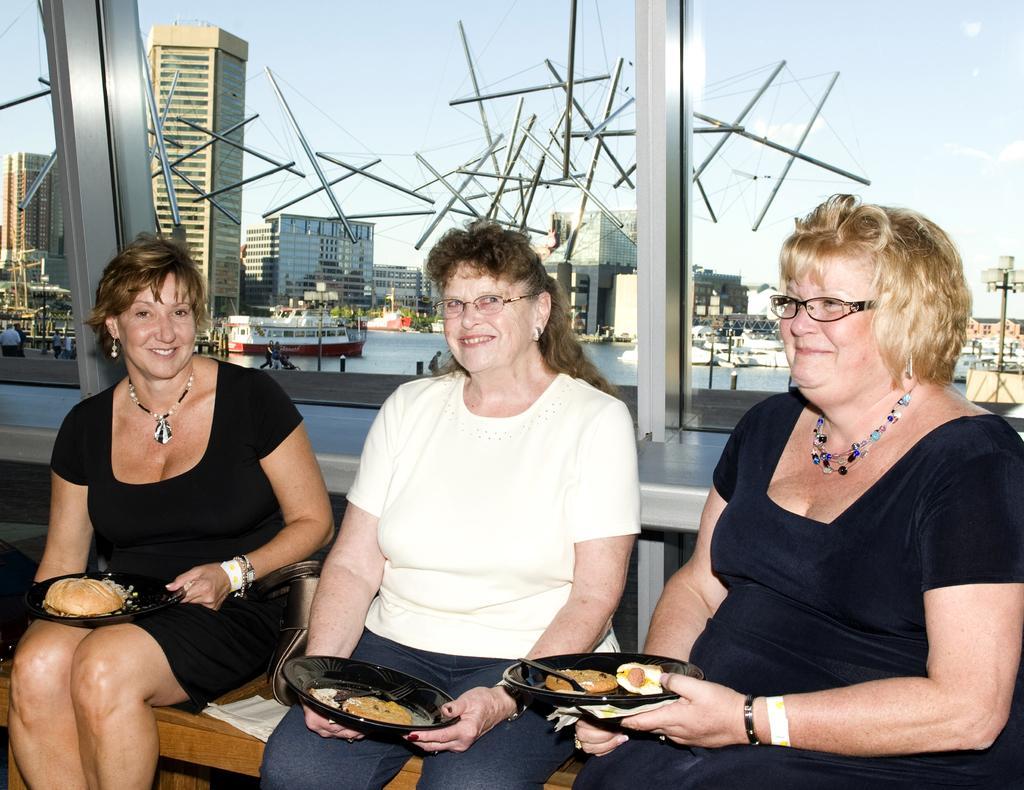In one or two sentences, can you explain what this image depicts? In this picture we can see three women smiling and holding plates with their hands and sitting on a wooden surface and on these planets we can see food items and in the background we can see buildings, boats on the water, some people and some objects and the sky. 